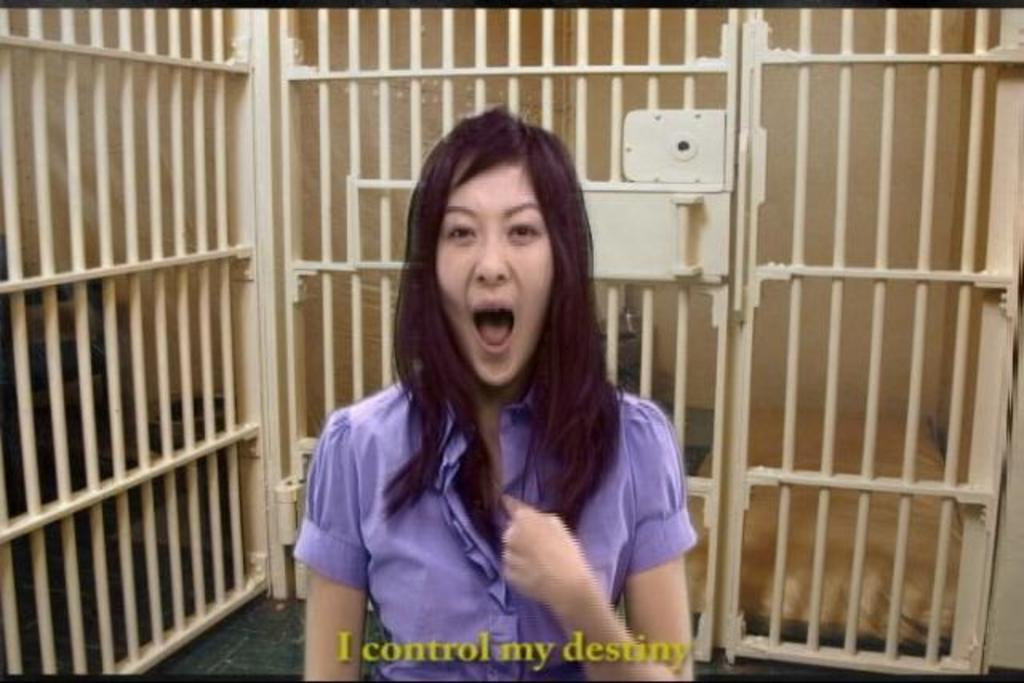Who is the main subject in the image? There is a lady in the center of the image. What can be seen in the background of the image? There are grills and a wall in the background of the image. Is there any text present in the image? Yes, there is text at the bottom of the image. What is the lady's hair color in the image? The provided facts do not mention the lady's hair color, so it cannot be determined from the image. 